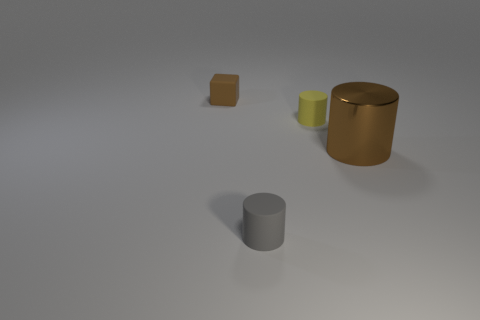What number of other objects are there of the same size as the brown metal cylinder?
Offer a very short reply. 0. Does the big object have the same color as the rubber cylinder behind the small gray matte cylinder?
Your answer should be compact. No. What number of spheres are gray rubber objects or small yellow rubber things?
Ensure brevity in your answer.  0. Are there any other things of the same color as the metallic cylinder?
Your answer should be very brief. Yes. The tiny thing on the left side of the rubber cylinder that is left of the yellow cylinder is made of what material?
Make the answer very short. Rubber. Does the yellow object have the same material as the small object behind the small yellow rubber cylinder?
Ensure brevity in your answer.  Yes. How many things are small rubber objects that are in front of the brown cylinder or tiny gray cylinders?
Offer a terse response. 1. Is there a matte ball of the same color as the large thing?
Offer a terse response. No. There is a large metal object; is it the same shape as the brown thing that is behind the big object?
Your answer should be very brief. No. How many tiny matte objects are behind the large brown metallic cylinder and in front of the rubber cube?
Your response must be concise. 1. 